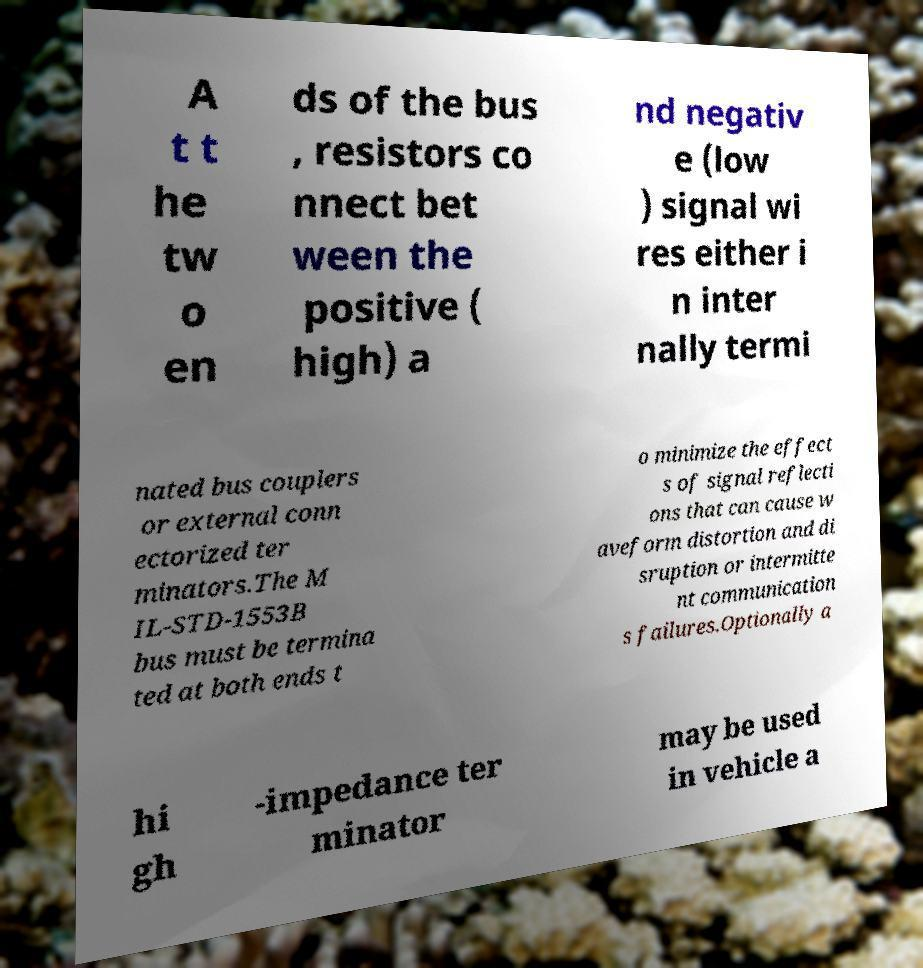I need the written content from this picture converted into text. Can you do that? A t t he tw o en ds of the bus , resistors co nnect bet ween the positive ( high) a nd negativ e (low ) signal wi res either i n inter nally termi nated bus couplers or external conn ectorized ter minators.The M IL-STD-1553B bus must be termina ted at both ends t o minimize the effect s of signal reflecti ons that can cause w aveform distortion and di sruption or intermitte nt communication s failures.Optionally a hi gh -impedance ter minator may be used in vehicle a 